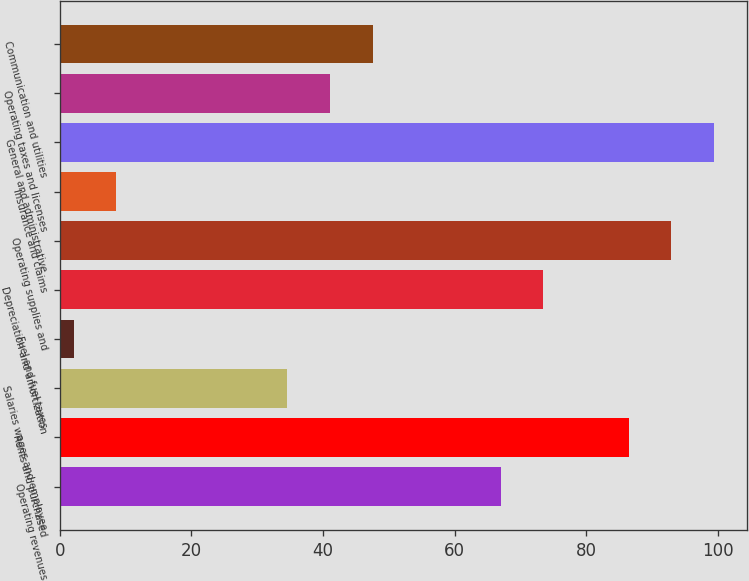Convert chart. <chart><loc_0><loc_0><loc_500><loc_500><bar_chart><fcel>Operating revenues<fcel>Rents and purchased<fcel>Salaries wages and employee<fcel>Fuel and fuel taxes<fcel>Depreciation and amortization<fcel>Operating supplies and<fcel>Insurance and claims<fcel>General and administrative<fcel>Operating taxes and licenses<fcel>Communication and utilities<nl><fcel>67<fcel>86.47<fcel>34.55<fcel>2.1<fcel>73.49<fcel>92.96<fcel>8.59<fcel>99.45<fcel>41.04<fcel>47.53<nl></chart> 